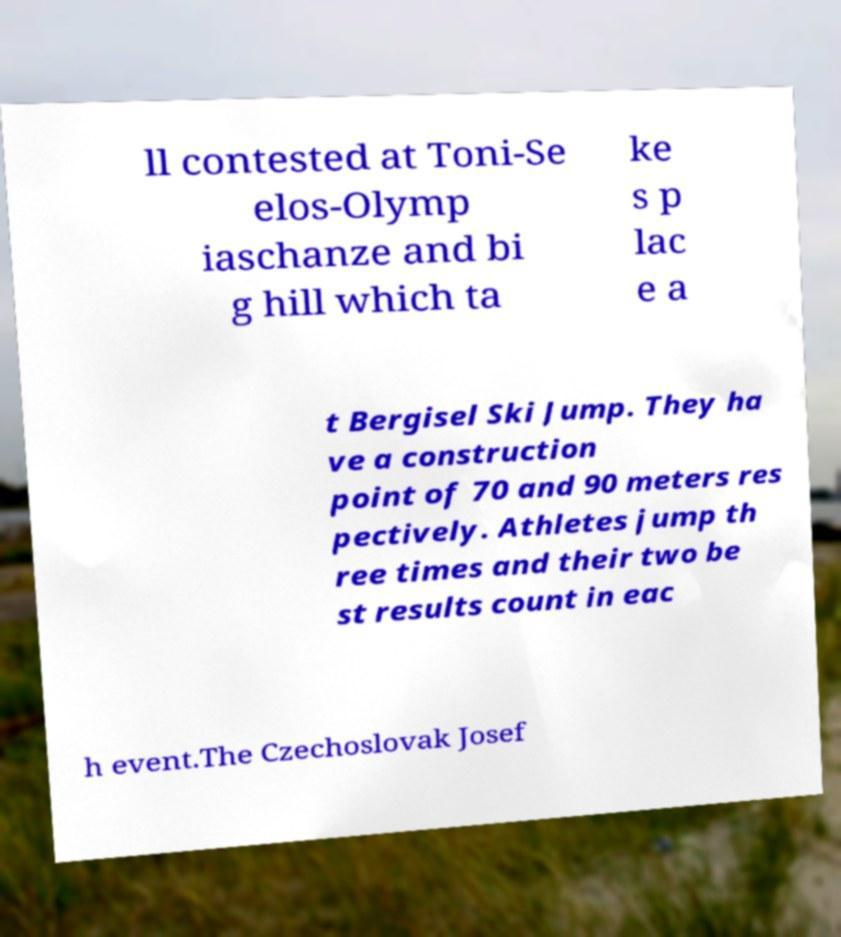Please read and relay the text visible in this image. What does it say? ll contested at Toni-Se elos-Olymp iaschanze and bi g hill which ta ke s p lac e a t Bergisel Ski Jump. They ha ve a construction point of 70 and 90 meters res pectively. Athletes jump th ree times and their two be st results count in eac h event.The Czechoslovak Josef 